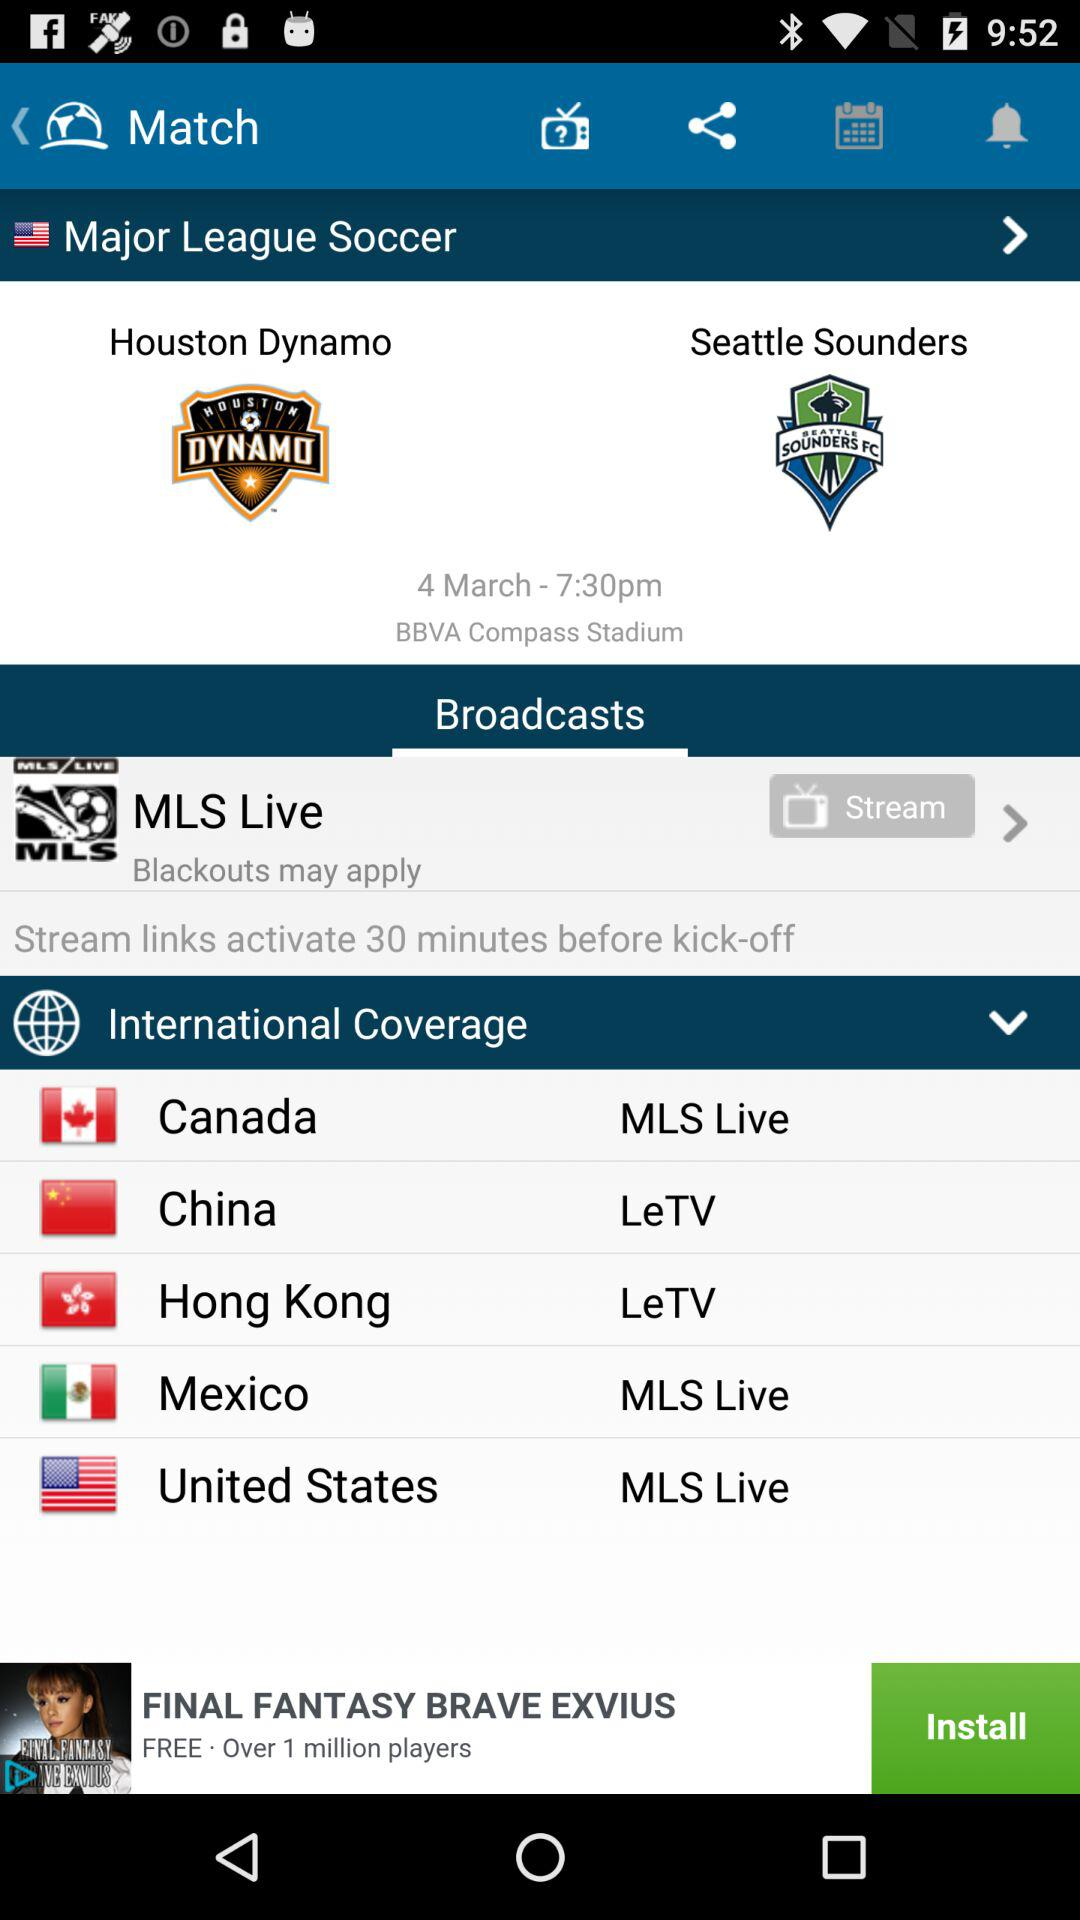What is the name of the tournament? The name of the tournament is "Major League Soccer". 